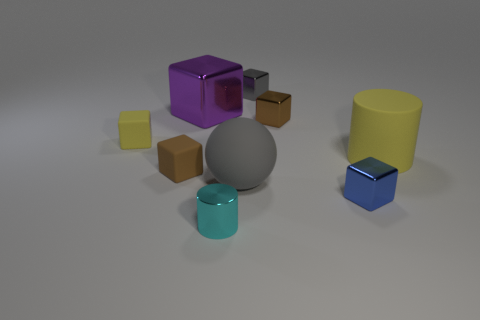What is the size of the gray thing in front of the brown block that is behind the large yellow thing? The gray object appears to be a medium-sized sphere relative to the other items in the picture. Its size is significant but smaller than the yellow cylindrical container and the purple cube, indicating it is not 'large' as previously mentioned but rather of a moderate dimension. 